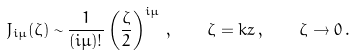<formula> <loc_0><loc_0><loc_500><loc_500>J _ { i \mu } ( \zeta ) \sim \frac { 1 } { ( i \mu ) ! } \left ( \frac { \zeta } { 2 } \right ) ^ { i \mu } \, , \quad \zeta = k z \, , \quad \zeta \rightarrow 0 \, .</formula> 